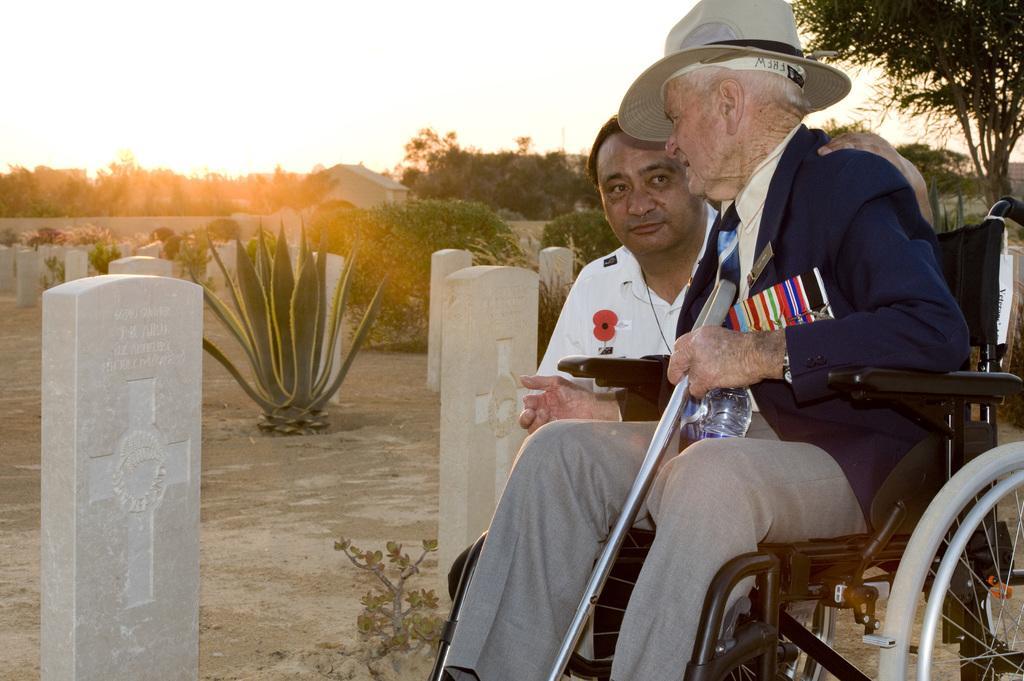Describe this image in one or two sentences. In this picture we can see a person sitting on a wheelchair on the ground, he is holding a stick, bottle, beside this person we can see another person, here we can see plants, graves, houses, trees and we can see sky in the background. 